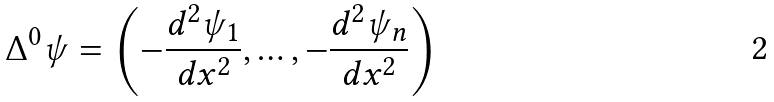<formula> <loc_0><loc_0><loc_500><loc_500>\Delta ^ { 0 } \psi = \left ( - \frac { d ^ { 2 } \psi _ { 1 } } { d x ^ { 2 } } , \dots , - \frac { d ^ { 2 } \psi _ { n } } { d x ^ { 2 } } \right )</formula> 